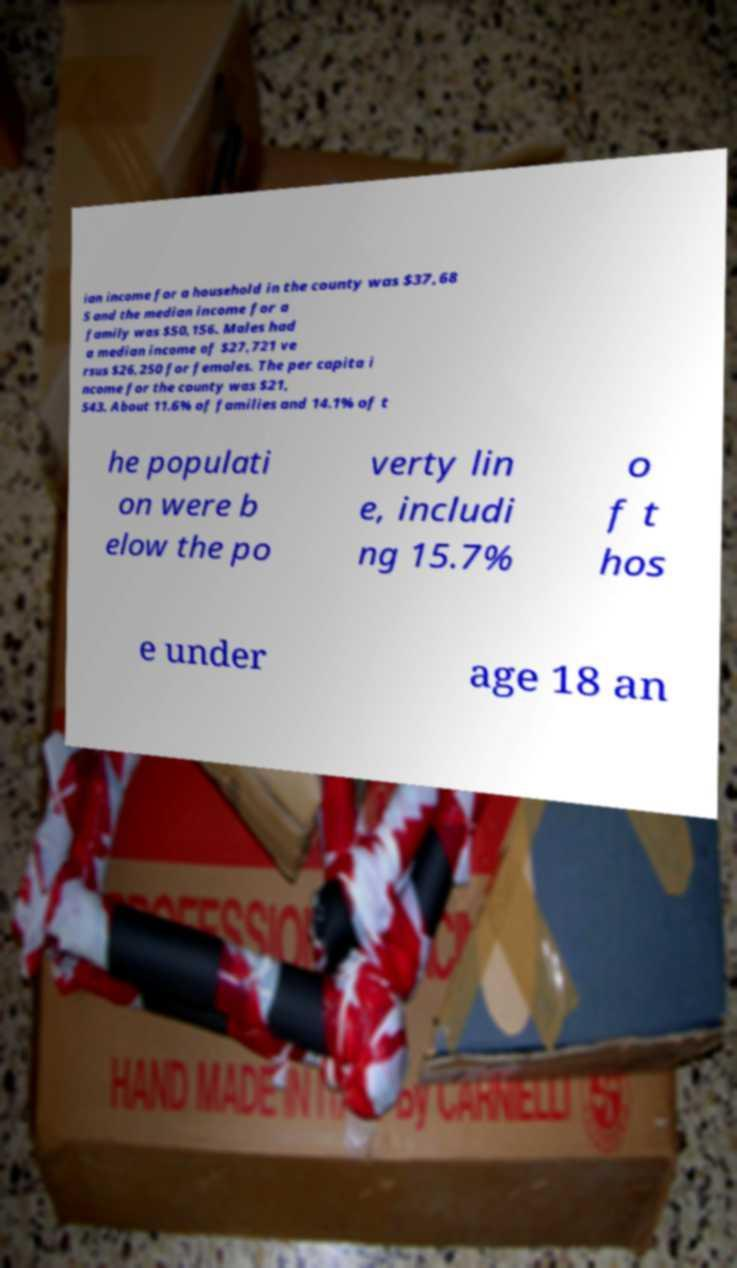Could you assist in decoding the text presented in this image and type it out clearly? ian income for a household in the county was $37,68 5 and the median income for a family was $50,156. Males had a median income of $27,721 ve rsus $26,250 for females. The per capita i ncome for the county was $21, 543. About 11.6% of families and 14.1% of t he populati on were b elow the po verty lin e, includi ng 15.7% o f t hos e under age 18 an 